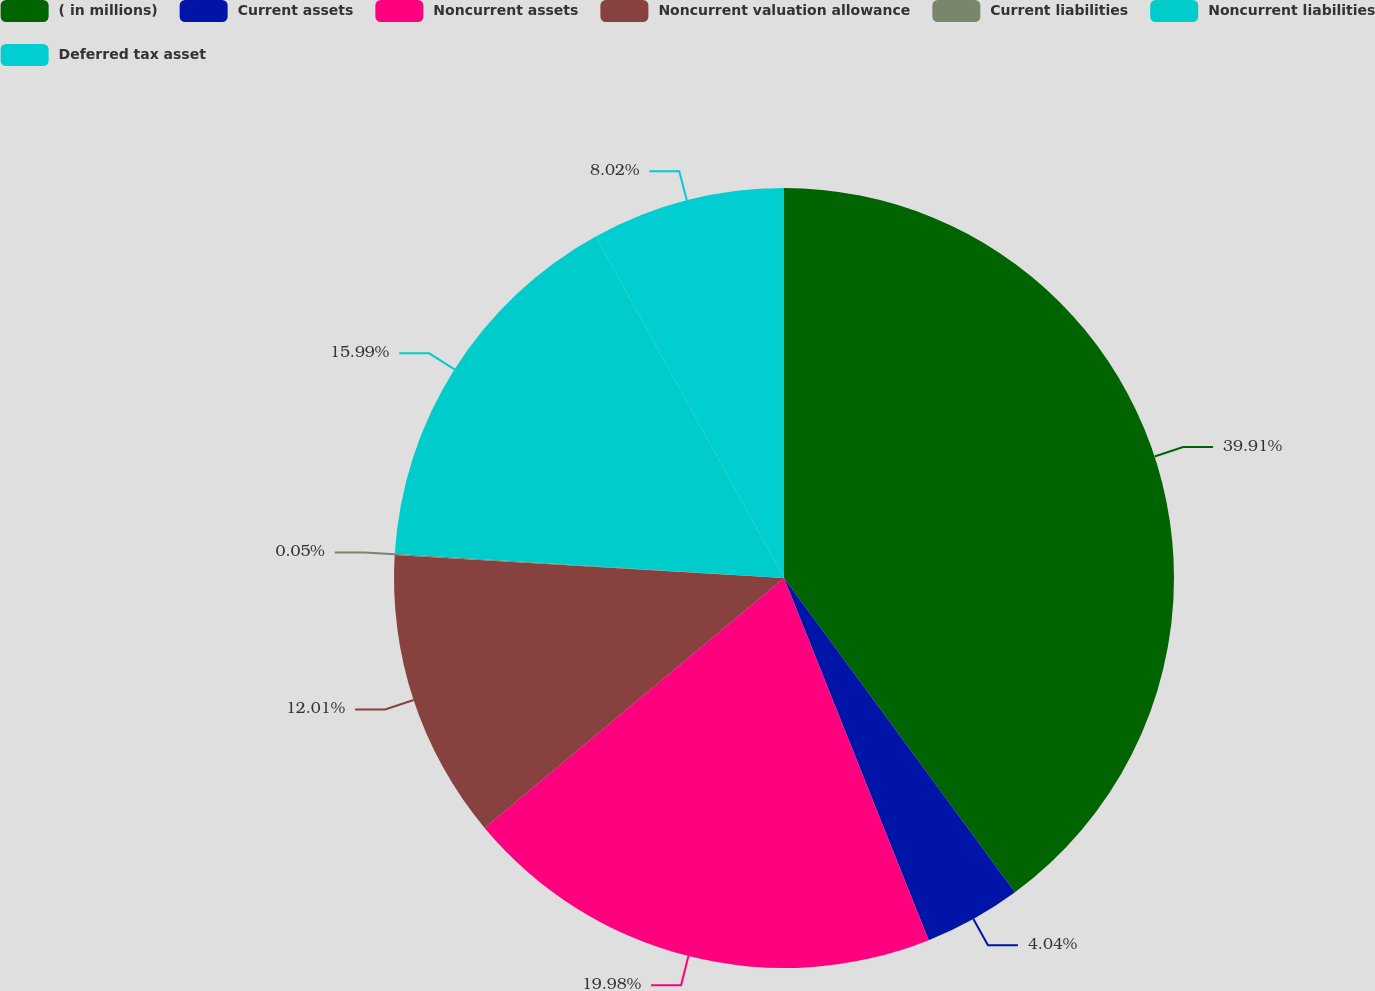Convert chart to OTSL. <chart><loc_0><loc_0><loc_500><loc_500><pie_chart><fcel>( in millions)<fcel>Current assets<fcel>Noncurrent assets<fcel>Noncurrent valuation allowance<fcel>Current liabilities<fcel>Noncurrent liabilities<fcel>Deferred tax asset<nl><fcel>39.91%<fcel>4.04%<fcel>19.98%<fcel>12.01%<fcel>0.05%<fcel>15.99%<fcel>8.02%<nl></chart> 